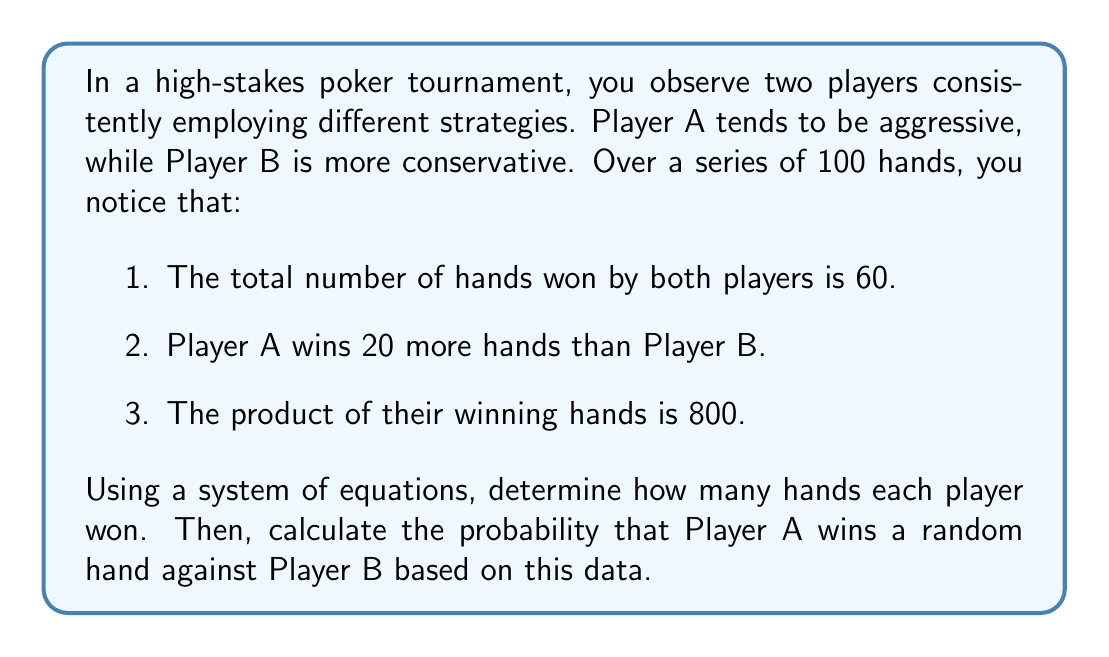Show me your answer to this math problem. Let's approach this problem step-by-step using a system of equations:

1. Let $x$ be the number of hands won by Player A, and $y$ be the number of hands won by Player B.

2. From the given information, we can form three equations:

   Equation 1: $x + y = 60$ (total hands won)
   Equation 2: $x = y + 20$ (Player A wins 20 more hands)
   Equation 3: $xy = 800$ (product of winning hands)

3. From Equation 2, we can express $x$ in terms of $y$:
   $x = y + 20$

4. Substitute this into Equation 1:
   $(y + 20) + y = 60$
   $2y + 20 = 60$
   $2y = 40$
   $y = 20$

5. Now we know $y = 20$, we can find $x$:
   $x = 20 + 20 = 40$

6. Let's verify using Equation 3:
   $xy = 40 * 20 = 800$ (which matches)

7. To calculate the probability that Player A wins a random hand:
   Total hands played = 100
   Hands won by Player A = 40
   
   Probability = $\frac{\text{Favorable outcomes}}{\text{Total outcomes}} = \frac{40}{100} = 0.4$ or 40%

This analysis provides insights into the effectiveness of aggressive vs. conservative strategies in this particular tournament setting.
Answer: Player A won 40 hands, and Player B won 20 hands. The probability that Player A wins a random hand against Player B is 0.4 or 40%. 